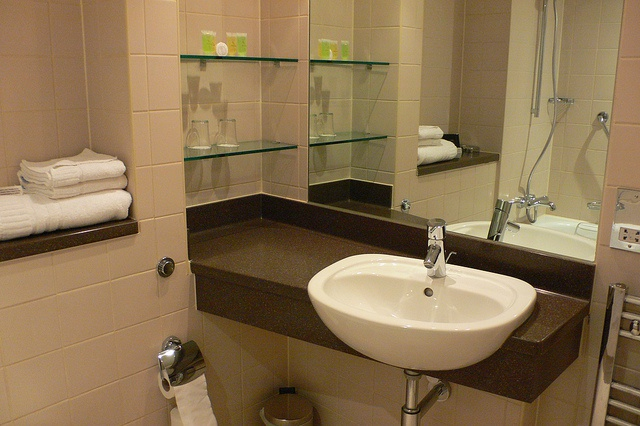Describe the objects in this image and their specific colors. I can see sink in gray, tan, and beige tones, cup in gray and tan tones, cup in gray and tan tones, and cup in gray and olive tones in this image. 